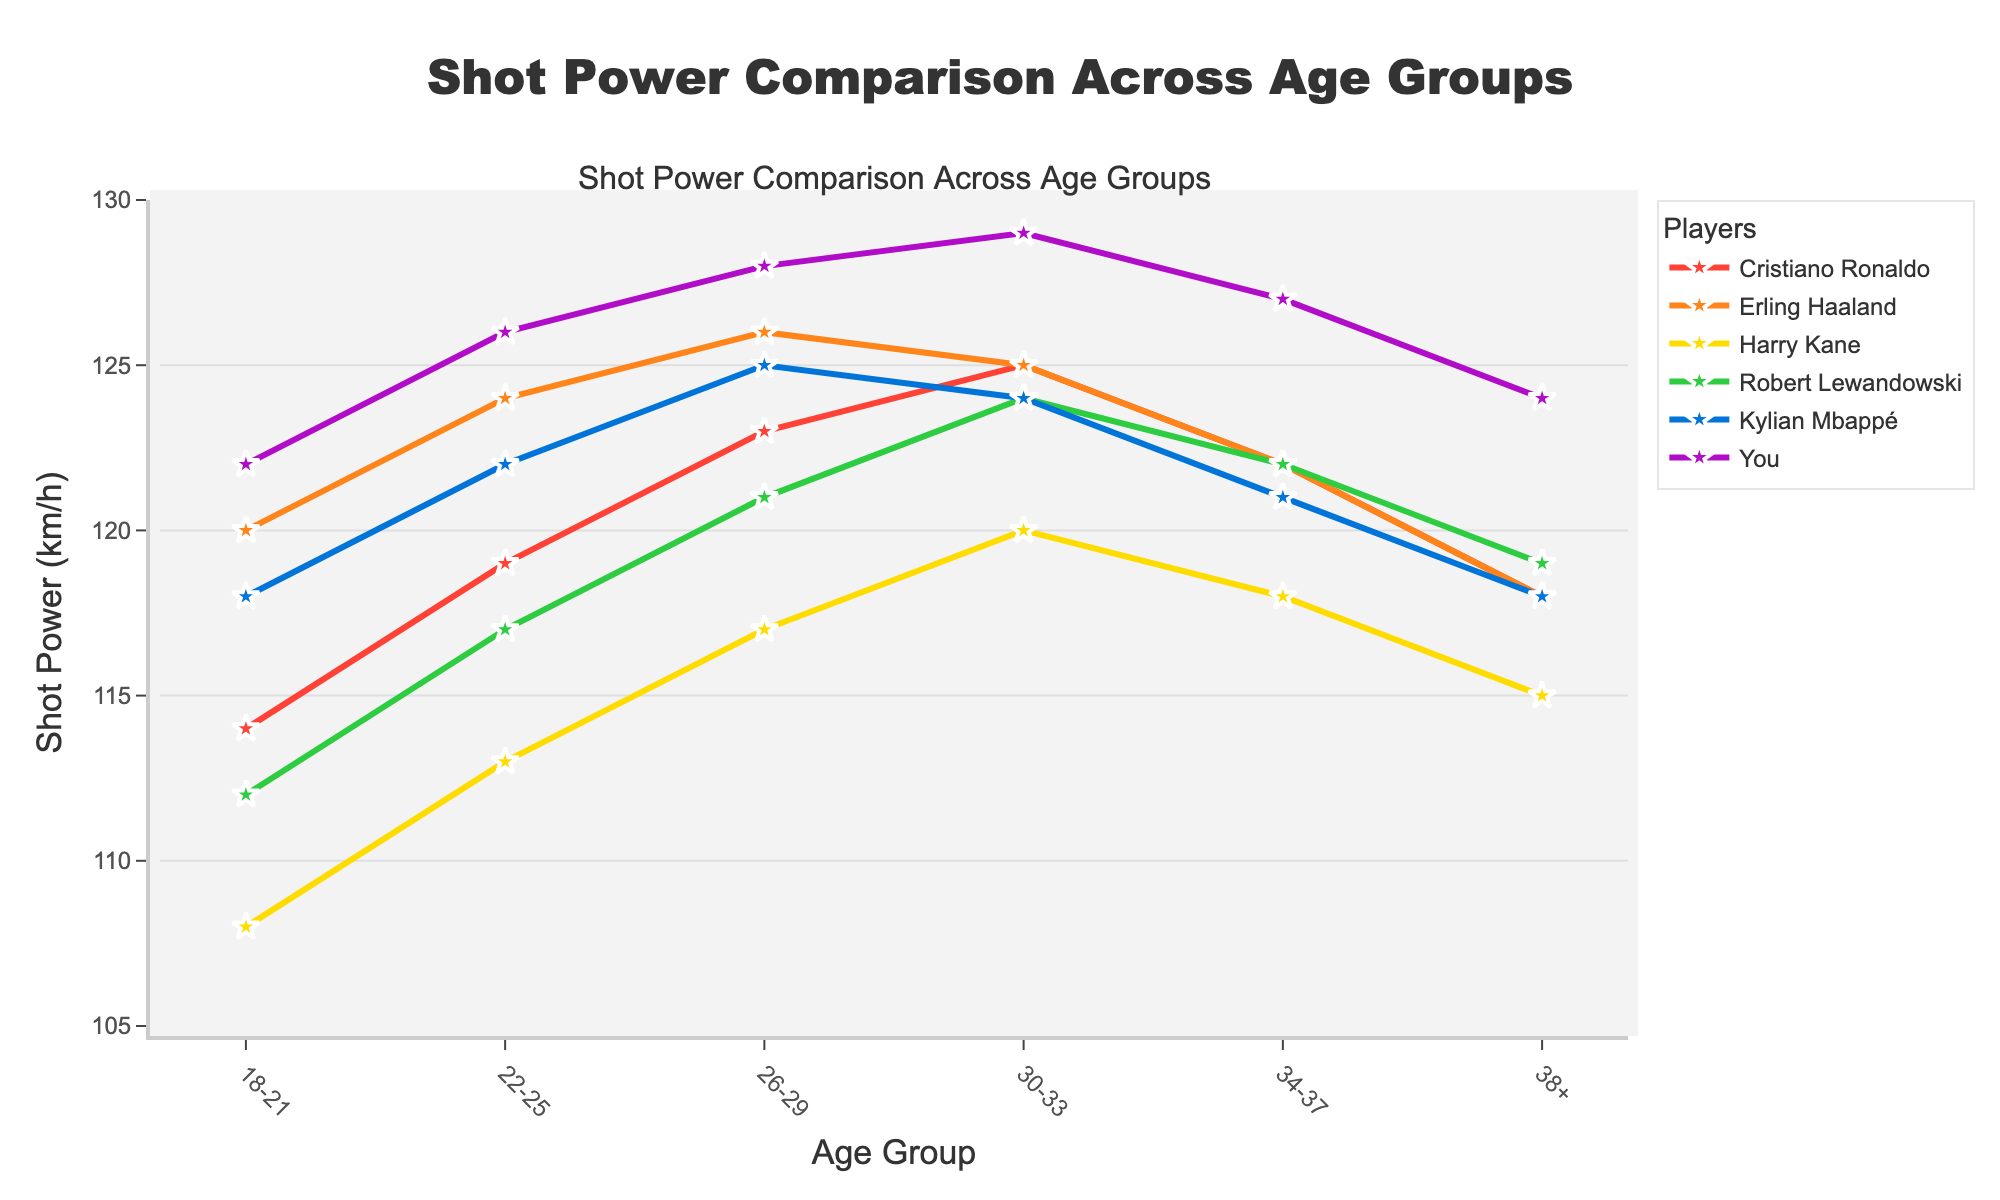Which player has the highest shot power in the 18-21 age group? Look for the highest value in the 18-21 age group column. The values are 114, 120, 108, 112, 118, and 122. The highest value is 122, attributed to "You".
Answer: You How does Cristiano Ronaldo's shot power compare at ages 30-33 versus 34-37? At ages 30-33, Ronaldo's shot power is 125 km/h, and at ages 34-37, it is 122 km/h. The difference is 125 - 122 = 3 km/h. Ronaldo's shot power drops by 3 km/h.
Answer: Drops by 3 km/h What is the average shot power of Kylian Mbappé across all age groups? Sum up Mbappé's shot power values across all age groups: 118 + 122 + 125 + 124 + 121 + 118 = 728. There are 6 age groups. The average is 728 / 6 = 121.33 km/h.
Answer: 121.33 km/h Whose shot power increases the most from 22-25 to 26-29 age groups? Calculate the difference for all players: Cristiano Ronaldo (+4), Erling Haaland (+2), Harry Kane (+4), Robert Lewandowski (+4), Kylian Mbappé (+3), You (+2). The largest increase is for Cristiano Ronaldo, Harry Kane, and Robert Lewandowski, each with +4.
Answer: Cristiano Ronaldo, Harry Kane, Robert Lewandowski Among the players aged 38+, who has the lowest shot power? Look for the lowest value in the 38+ age group column. The values are 118, 118, 115, 119, 118, and 124. The lowest value is 115, attributed to Harry Kane.
Answer: Harry Kane What is the range of shot power in the 26-29 age group? The 26-29 values are 123, 126, 117, 121, 125, and 128. The range is calculated as the maximum value minus the minimum value: 128 - 117 = 11 km/h.
Answer: 11 km/h Who has the most consistent shot power across all age groups (smallest range)? Calculate the range for each player: Ronaldo (125-114=11), Haaland (126-118=8), Kane (120-108=12), Lewandowski (124-112=12), Mbappé (125-118=7), You (129-122=7). The smallest range is 7, attributed to Kylian Mbappé and You.
Answer: Kylian Mbappé, You Between Erling Haaland and Robert Lewandowski, who maintains a higher shot power in more age groups? Compare Haaland and Lewandowski's shot power for each age group:
- 18-21: Haaland (120) > Lewandowski (112)
- 22-25: Haaland (124) > Lewandowski (117)
- 26-29: Haaland (126) > Lewandowski (121)
- 30-33: Haaland (125) > Lewandowski (124)
- 34-37: Haaland (122) = Lewandowski (122)
- 38+: Haaland (118) < Lewandowski (119)
Haaland has higher shot power in four age groups, Lewandowski in one, and they tie in one.
Answer: Haaland 